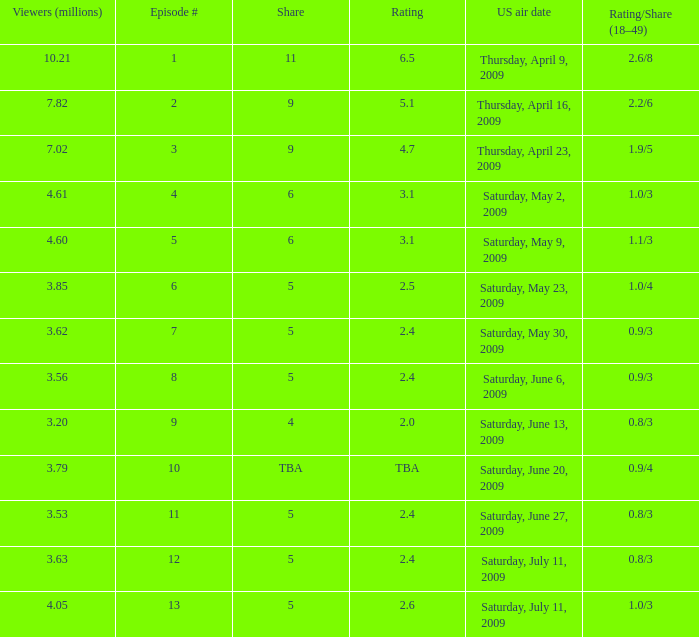What is the average number of million viewers that watched an episode before episode 11 with a share of 4? 3.2. 